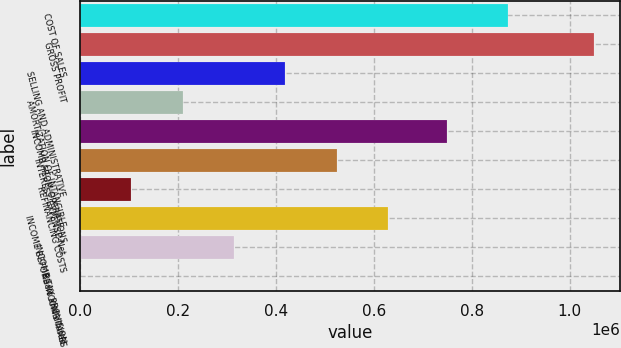<chart> <loc_0><loc_0><loc_500><loc_500><bar_chart><fcel>COST OF SALES<fcel>GROSS PROFIT<fcel>SELLING AND ADMINISTRATIVE<fcel>AMORTIZATION OF INTANGIBLE<fcel>INCOME FROM OPERATIONS<fcel>INTEREST EXPENSE-Net<fcel>REFINANCING COSTS<fcel>INCOME BEFORE INCOME TAXES<fcel>INCOME TAX PROVISION<fcel>Basic and diluted<nl><fcel>874838<fcel>1.04956e+06<fcel>419826<fcel>209914<fcel>749455<fcel>524782<fcel>104958<fcel>629738<fcel>314870<fcel>2.39<nl></chart> 